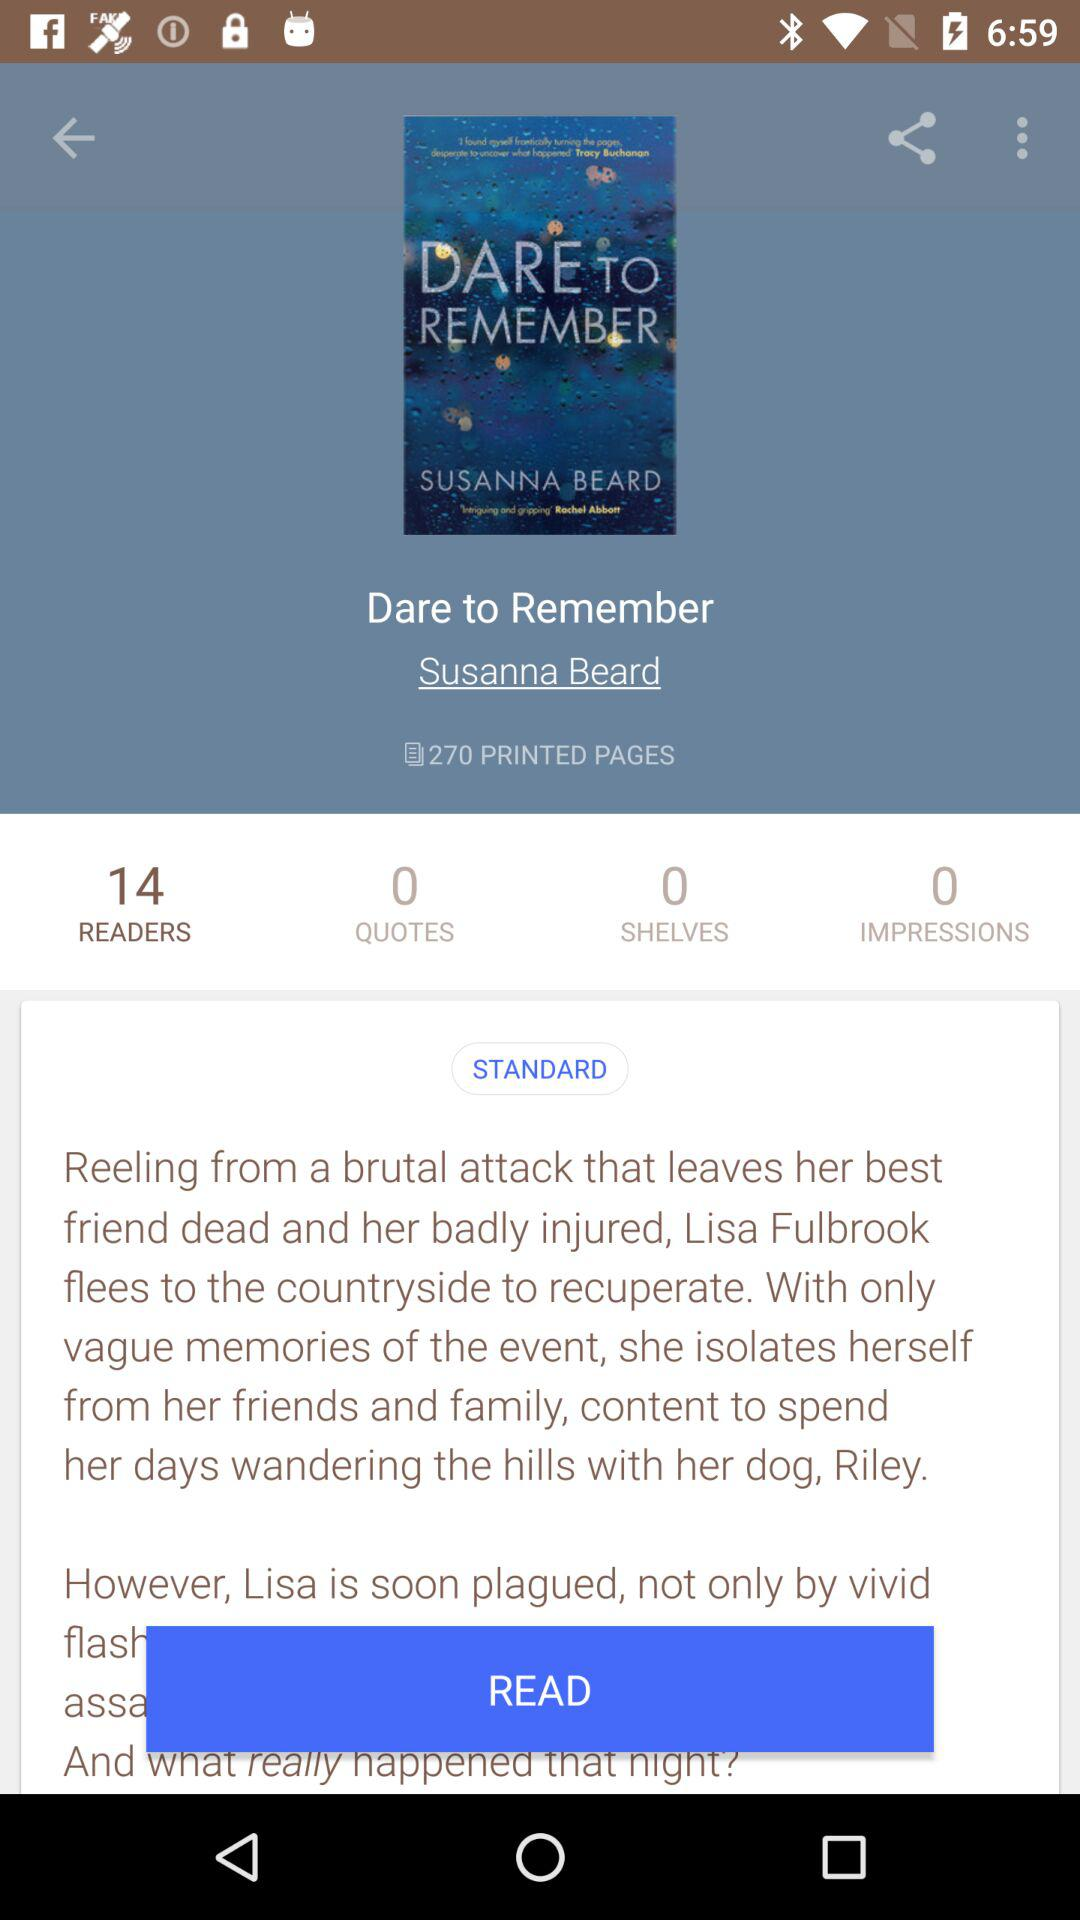Who's the author of the book "Dare to Remember"? The author of the book "Dare to Remember" is Susanna Beard. 